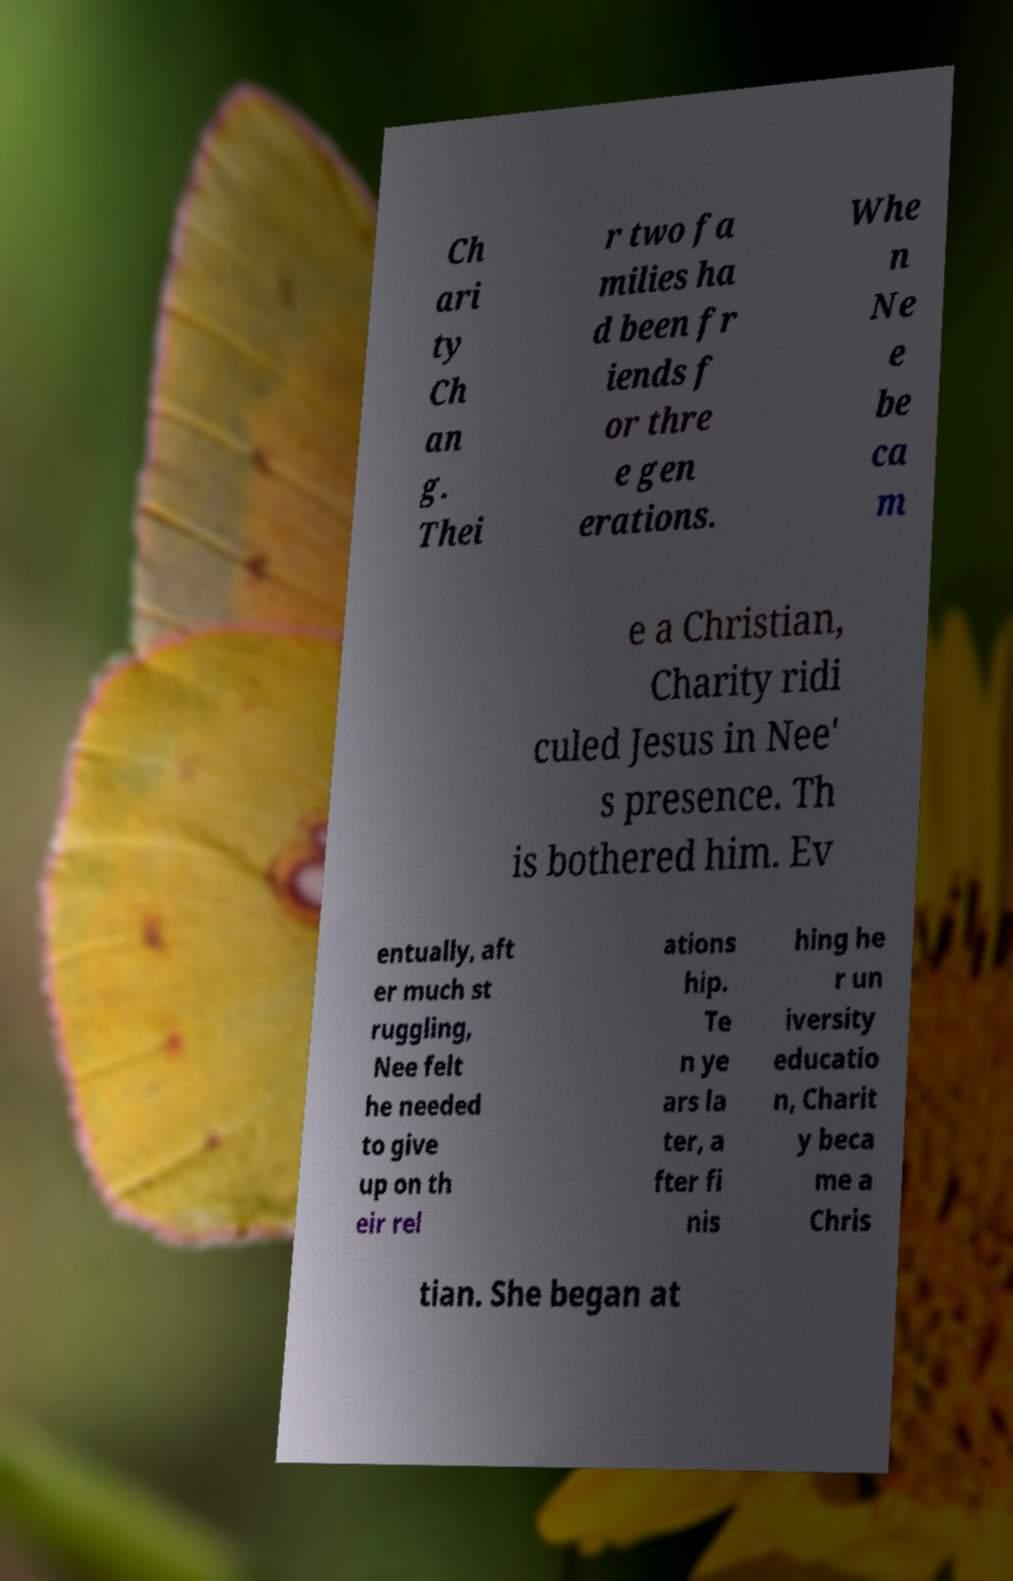I need the written content from this picture converted into text. Can you do that? Ch ari ty Ch an g. Thei r two fa milies ha d been fr iends f or thre e gen erations. Whe n Ne e be ca m e a Christian, Charity ridi culed Jesus in Nee' s presence. Th is bothered him. Ev entually, aft er much st ruggling, Nee felt he needed to give up on th eir rel ations hip. Te n ye ars la ter, a fter fi nis hing he r un iversity educatio n, Charit y beca me a Chris tian. She began at 